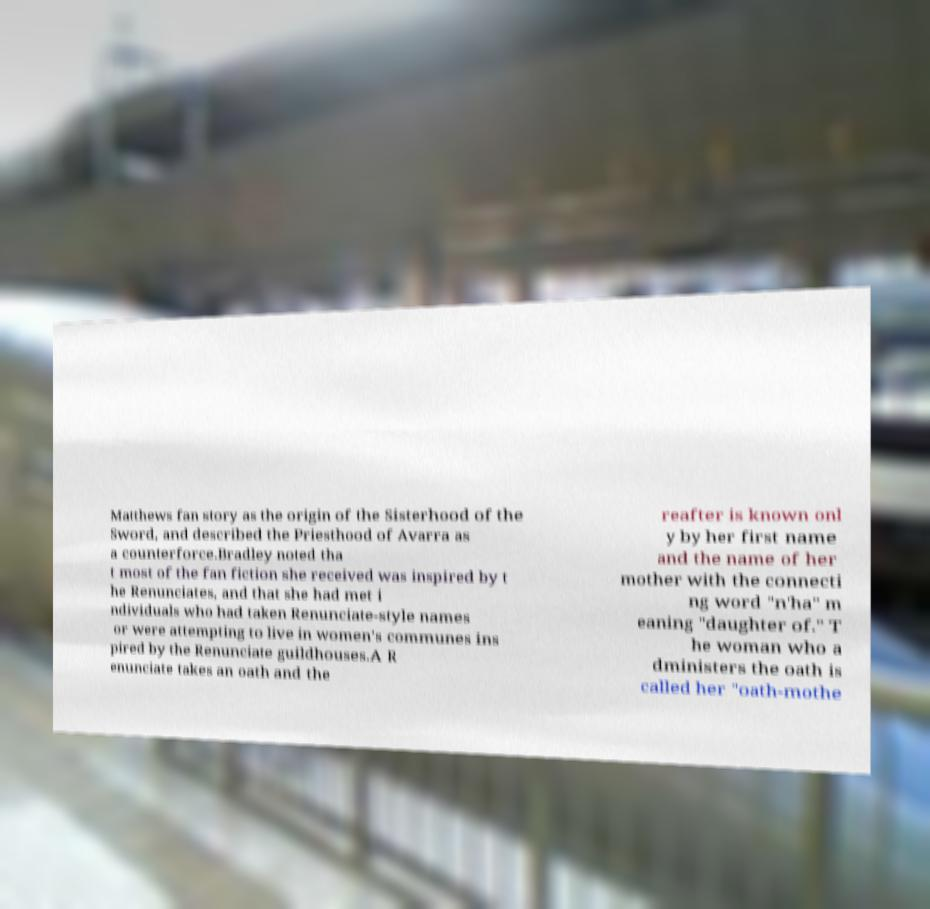Please read and relay the text visible in this image. What does it say? Matthews fan story as the origin of the Sisterhood of the Sword, and described the Priesthood of Avarra as a counterforce.Bradley noted tha t most of the fan fiction she received was inspired by t he Renunciates, and that she had met i ndividuals who had taken Renunciate-style names or were attempting to live in women's communes ins pired by the Renunciate guildhouses.A R enunciate takes an oath and the reafter is known onl y by her first name and the name of her mother with the connecti ng word "n'ha" m eaning "daughter of." T he woman who a dministers the oath is called her "oath-mothe 